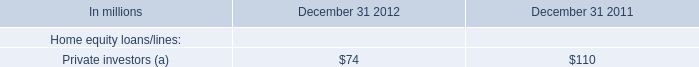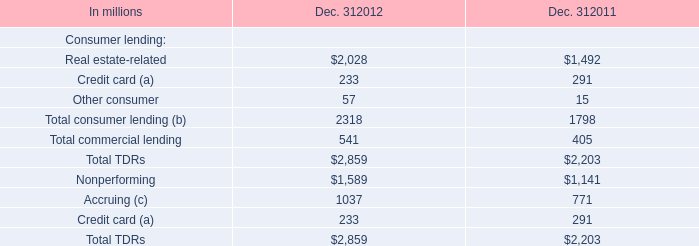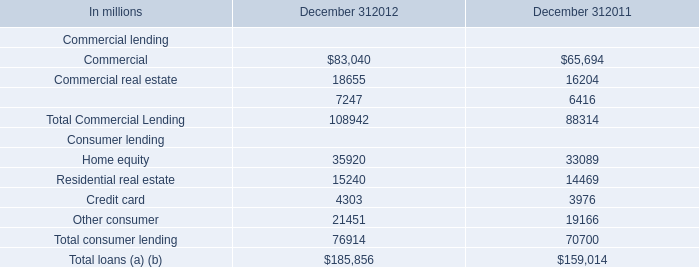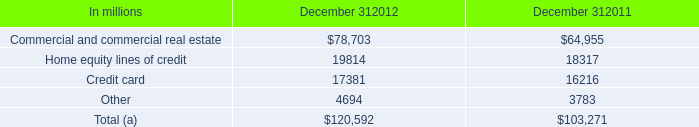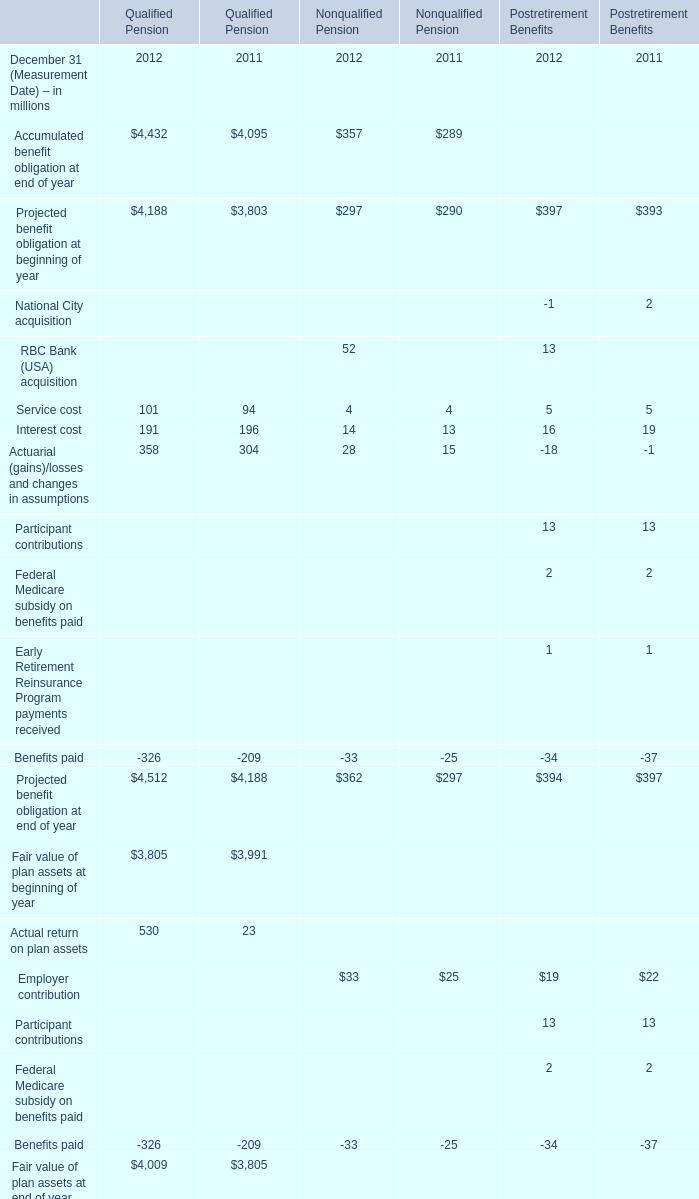In which years is Service cost greater than 1000 for Qualified Pension? 
Answer: 2012. 